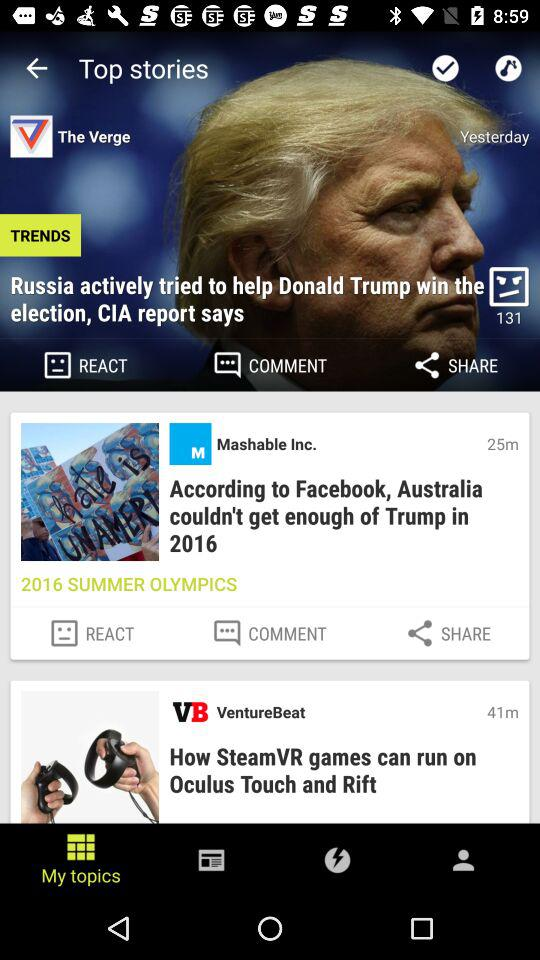What is the headline of the news posted 25 minutes ago? The headline of the news is "According to Facebook, Australia couldn't get enough of Trump in 2016". 